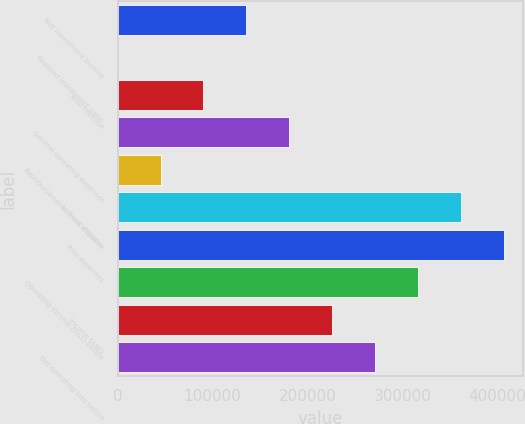Convert chart to OTSL. <chart><loc_0><loc_0><loc_500><loc_500><bar_chart><fcel>Net investment income<fcel>Realized investment gains<fcel>Total revenue<fcel>General operating expenses<fcel>Reimbursements from affiliates<fcel>Interest expense<fcel>Total expenses<fcel>Operating income (loss) before<fcel>Income taxes<fcel>Net operating loss before<nl><fcel>135493<fcel>1<fcel>90328.8<fcel>180657<fcel>45164.9<fcel>361312<fcel>406476<fcel>316148<fcel>225820<fcel>270984<nl></chart> 